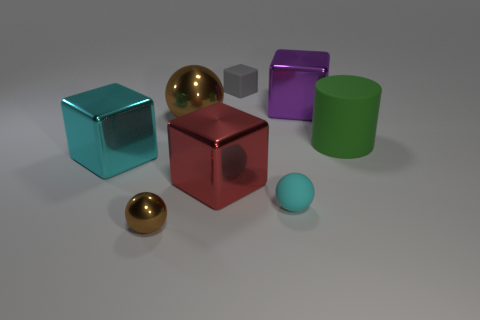Do the big shiny sphere and the tiny metallic ball have the same color?
Offer a terse response. Yes. What is the shape of the big object that is the same color as the rubber sphere?
Offer a terse response. Cube. Are there any shiny things to the left of the large metal object to the right of the matte block?
Your response must be concise. Yes. The gray object that is made of the same material as the green thing is what shape?
Ensure brevity in your answer.  Cube. Is there any other thing that is the same color as the rubber cylinder?
Your answer should be compact. No. What material is the big cyan object that is the same shape as the red metal object?
Provide a succinct answer. Metal. What number of other things are there of the same size as the red thing?
Make the answer very short. 4. There is a shiny thing that is the same color as the small shiny sphere; what size is it?
Give a very brief answer. Large. There is a metallic object that is to the right of the gray block; is its shape the same as the large brown shiny thing?
Make the answer very short. No. What number of other things are there of the same shape as the large brown thing?
Provide a short and direct response. 2. 